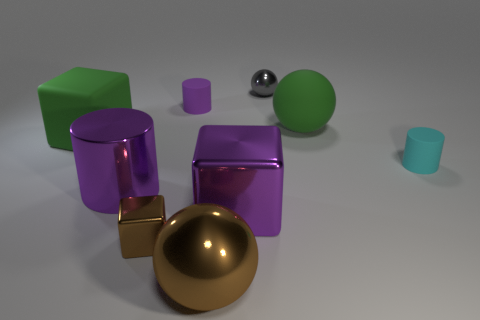There is another large purple thing that is the same shape as the purple rubber object; what is its material? The large purple object that shares the same shape as the purple rubber object appears to have a reflective surface with characteristics resembling metal, likely indicating that it is indeed made of metal. 